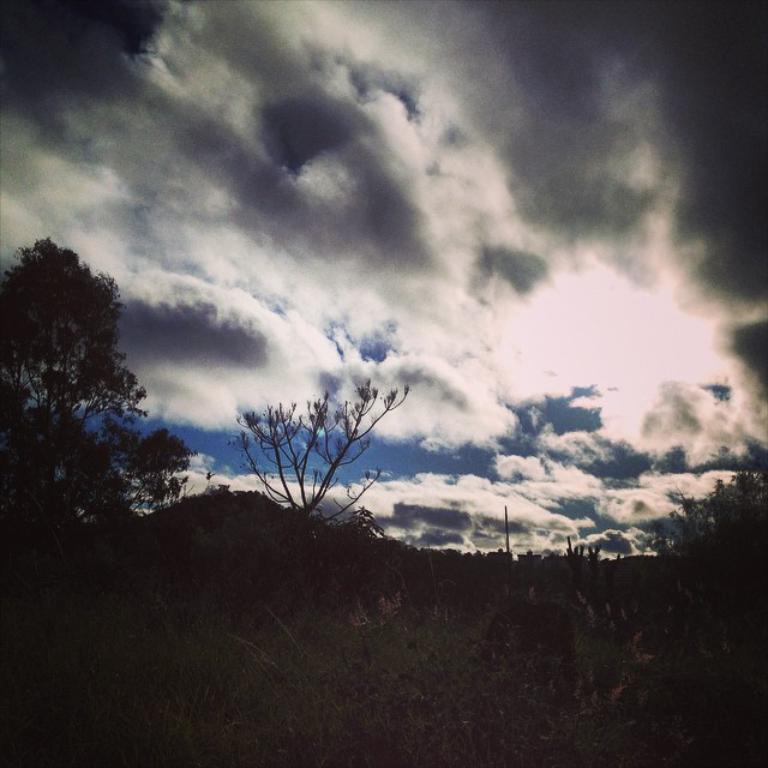Please provide a concise description of this image. In the picture we can see some plants and near to it, we can see a tree and in the background we can see a sky with clouds. 